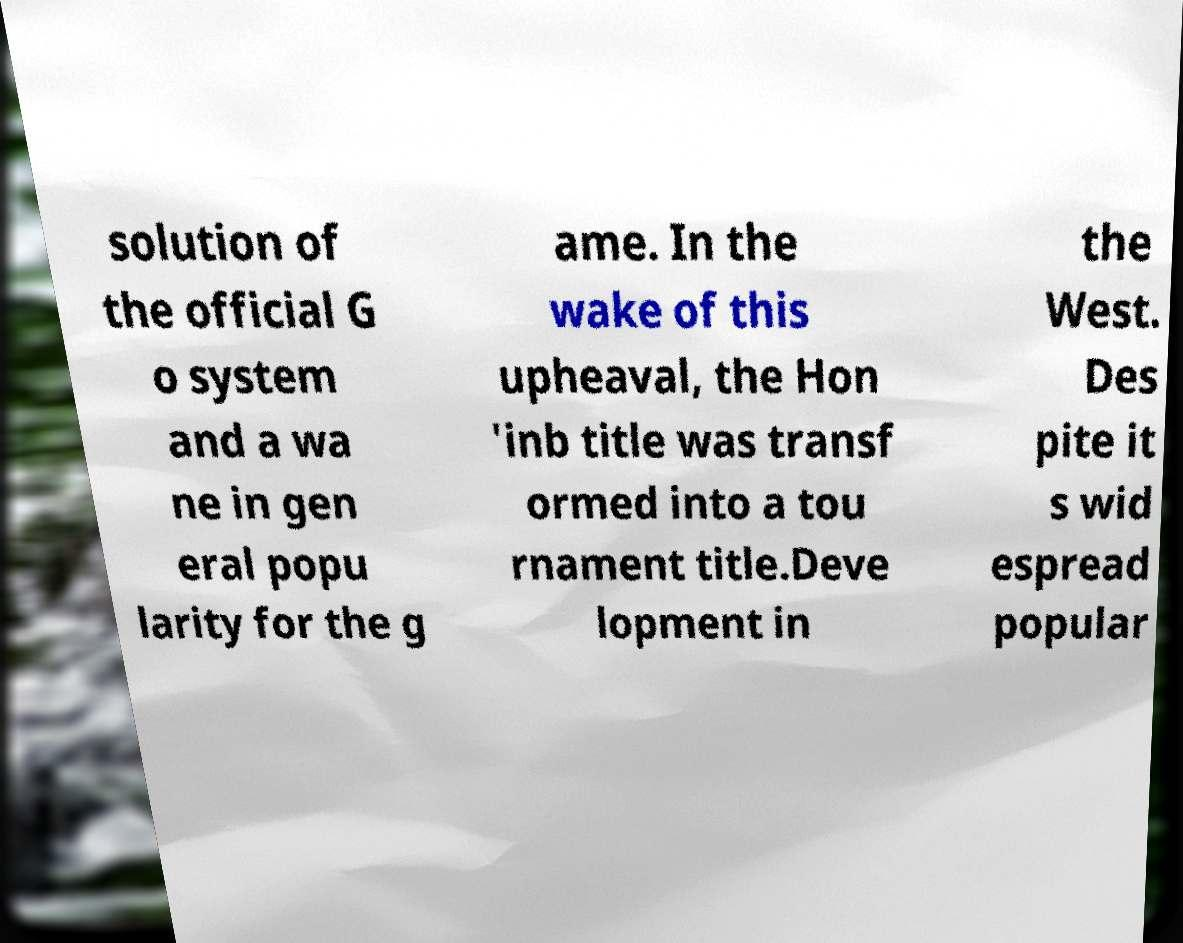Could you extract and type out the text from this image? solution of the official G o system and a wa ne in gen eral popu larity for the g ame. In the wake of this upheaval, the Hon 'inb title was transf ormed into a tou rnament title.Deve lopment in the West. Des pite it s wid espread popular 